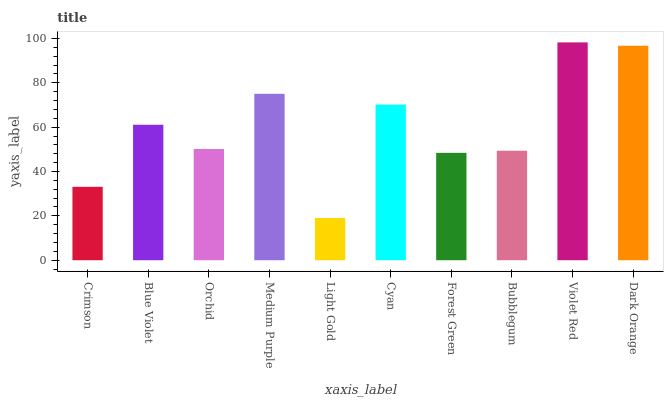Is Light Gold the minimum?
Answer yes or no. Yes. Is Violet Red the maximum?
Answer yes or no. Yes. Is Blue Violet the minimum?
Answer yes or no. No. Is Blue Violet the maximum?
Answer yes or no. No. Is Blue Violet greater than Crimson?
Answer yes or no. Yes. Is Crimson less than Blue Violet?
Answer yes or no. Yes. Is Crimson greater than Blue Violet?
Answer yes or no. No. Is Blue Violet less than Crimson?
Answer yes or no. No. Is Blue Violet the high median?
Answer yes or no. Yes. Is Orchid the low median?
Answer yes or no. Yes. Is Bubblegum the high median?
Answer yes or no. No. Is Blue Violet the low median?
Answer yes or no. No. 